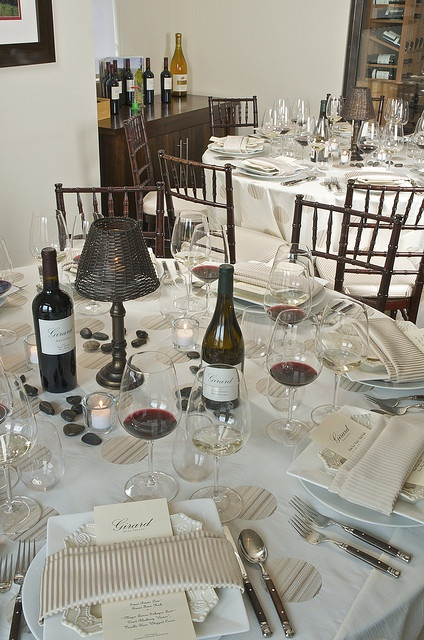Describe the objects in this image and their specific colors. I can see dining table in black, darkgray, and gray tones, wine glass in black, darkgray, lightgray, and gray tones, dining table in black, lightgray, darkgray, and tan tones, chair in black, ivory, and gray tones, and wine glass in black, darkgray, gray, and lightgray tones in this image. 